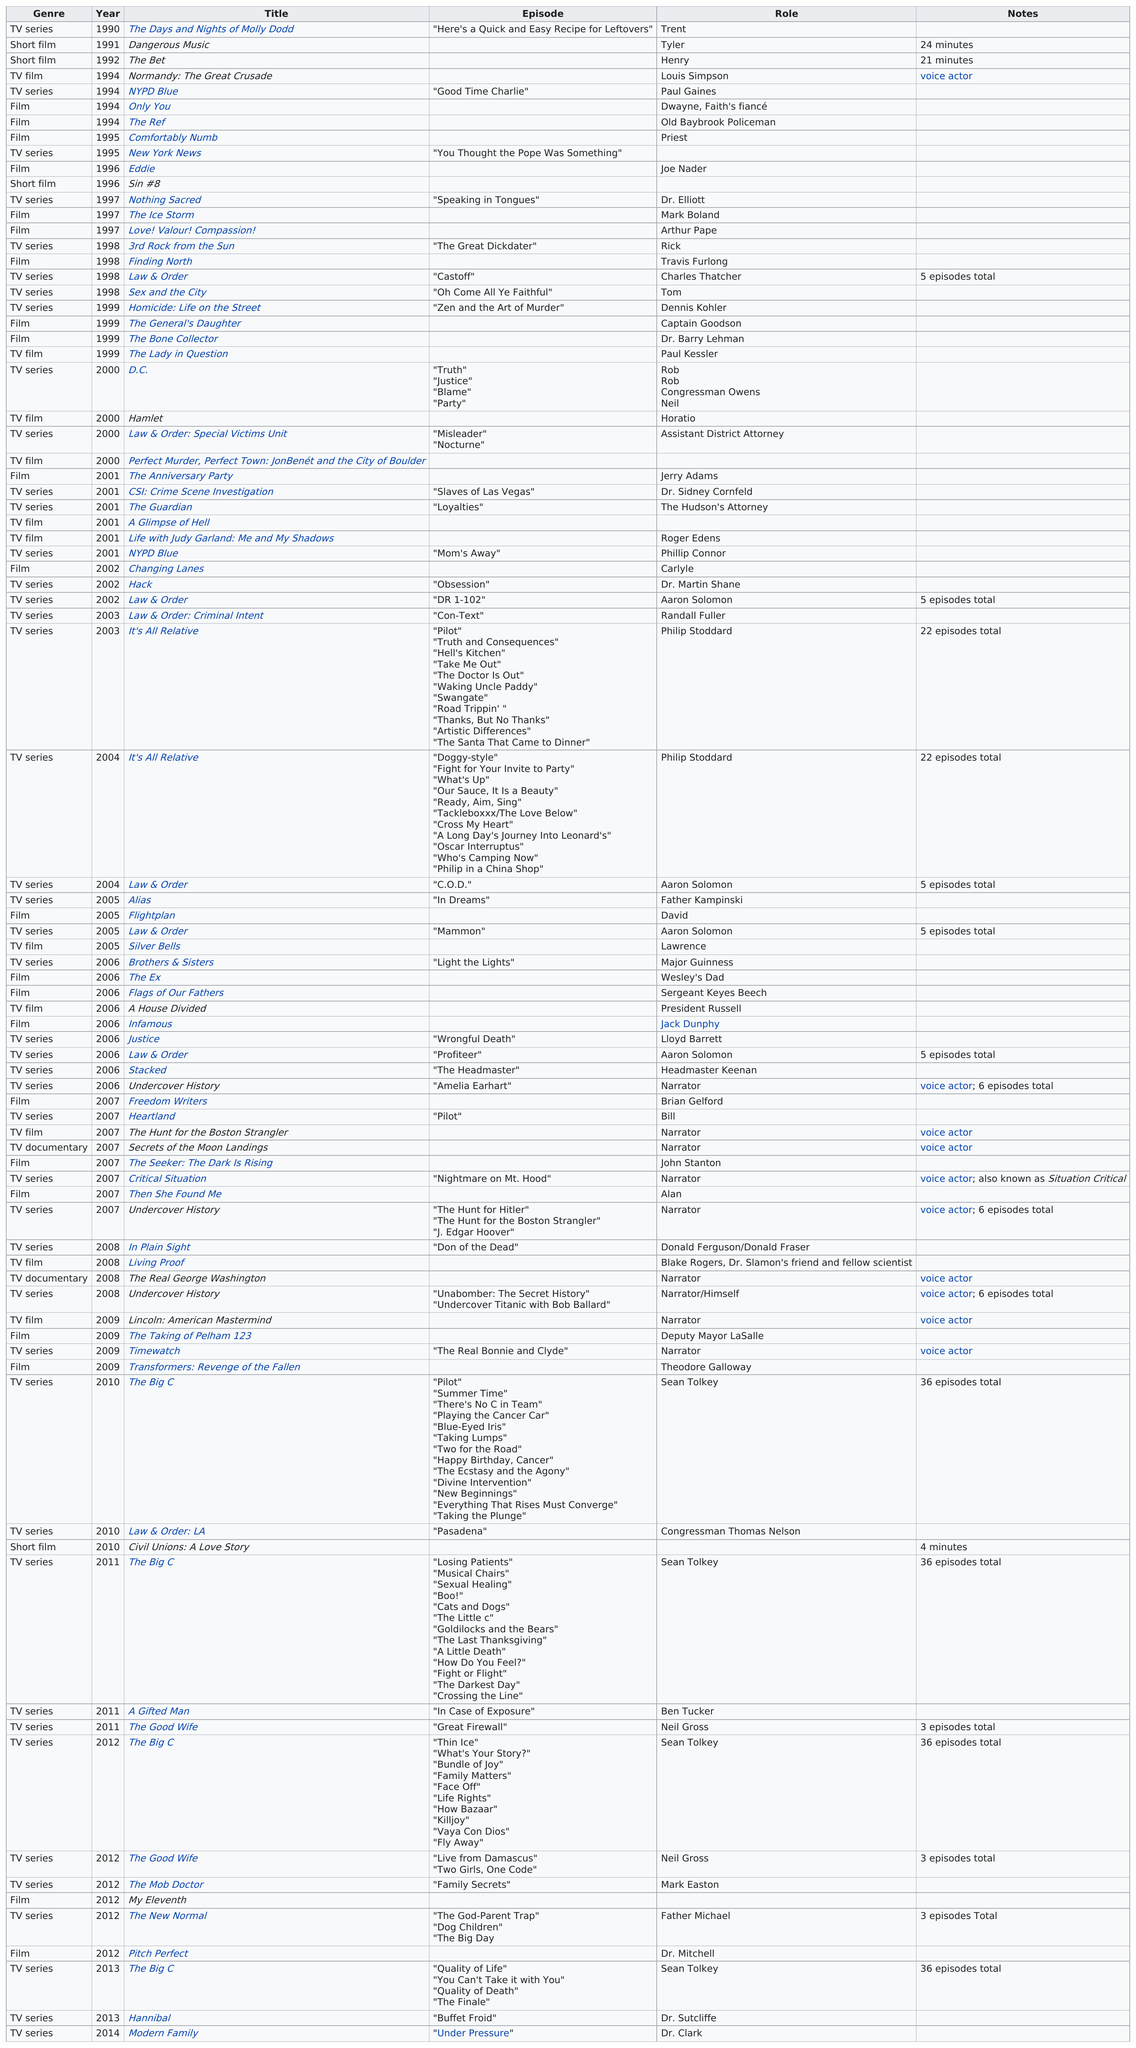Point out several critical features in this image. The first television series to air after "New York News" was "Eddie. I am not sure which TV series you are referring to. Could you please specify the name of the series? The year preceding Normandy: The Great Crusade was in 1992. The episode that follows Nypd Blue, titled "Mom's Away", is... As of the current date, the last filmography that he has contributed to is Modern Family. 